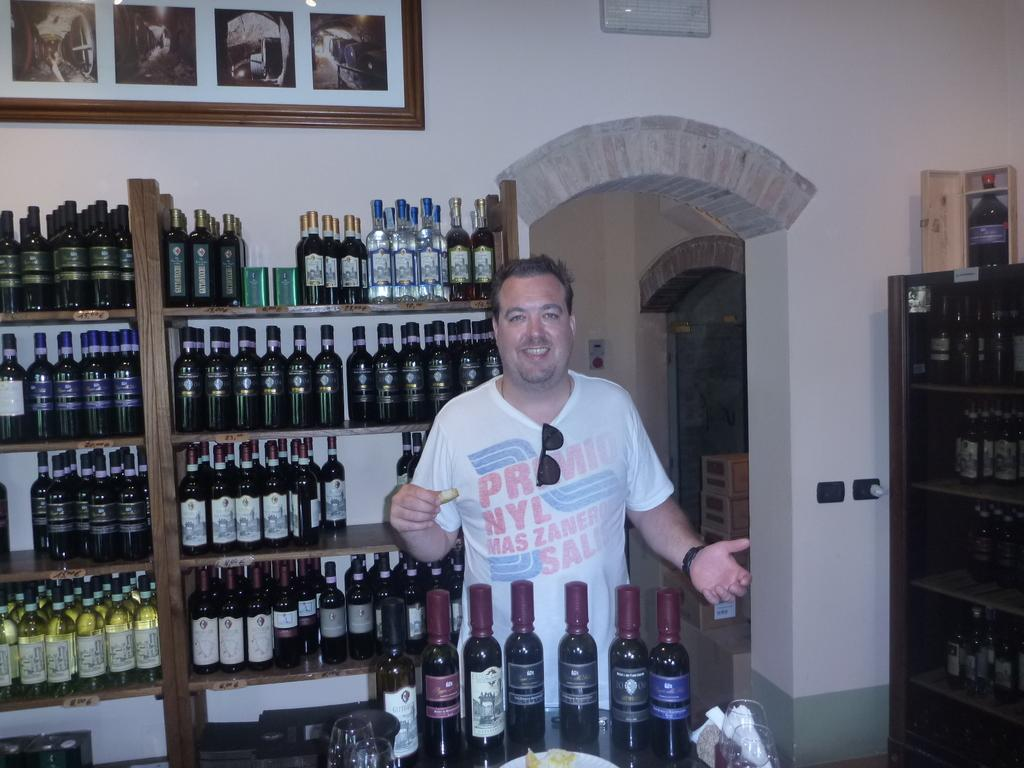<image>
Summarize the visual content of the image. A man wearing a t-shirt that has prmio on the front, stands behind a row of bottles. 